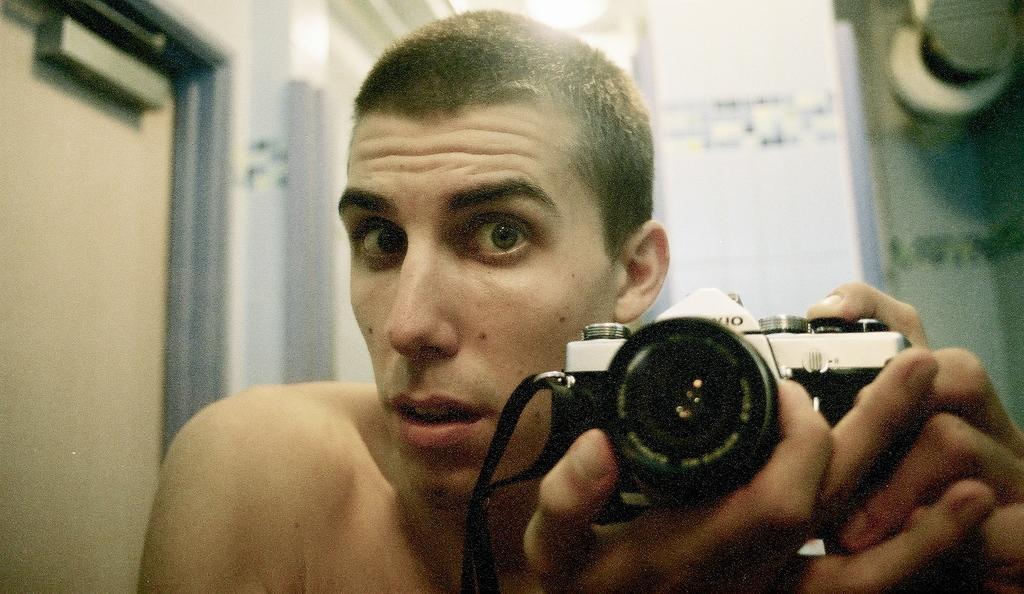Describe this image in one or two sentences. In this picture we can see a man , holding a camera in his hands. This is a door. On the background we can see a wall. 